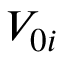<formula> <loc_0><loc_0><loc_500><loc_500>V _ { 0 i }</formula> 